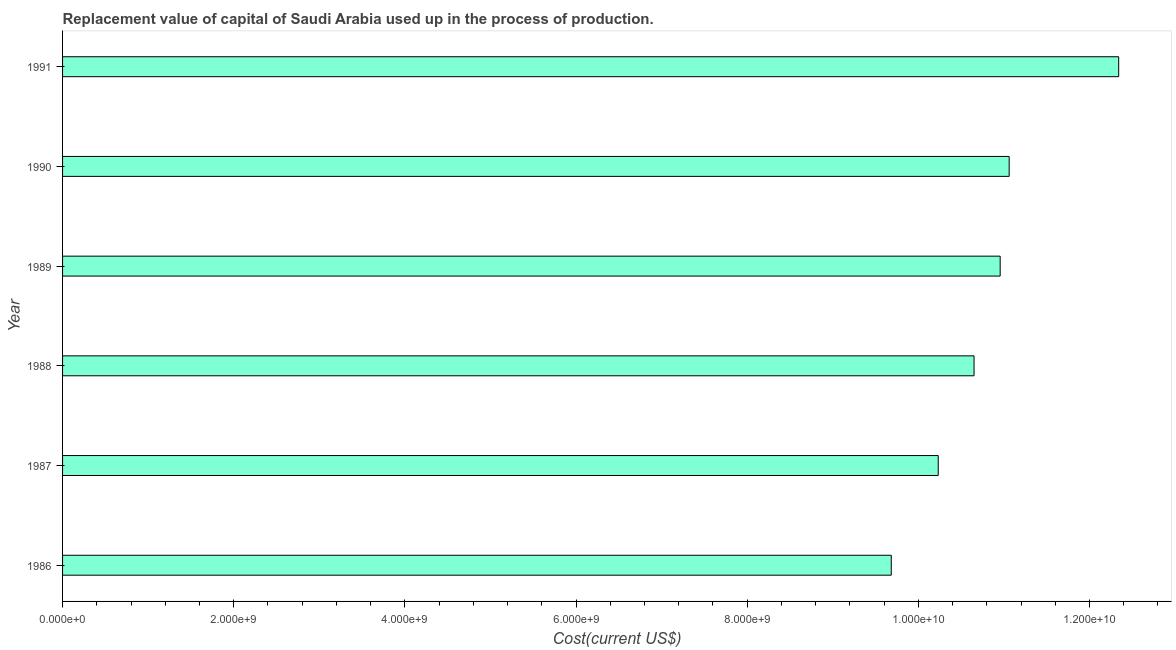Does the graph contain any zero values?
Give a very brief answer. No. Does the graph contain grids?
Offer a very short reply. No. What is the title of the graph?
Provide a short and direct response. Replacement value of capital of Saudi Arabia used up in the process of production. What is the label or title of the X-axis?
Ensure brevity in your answer.  Cost(current US$). What is the consumption of fixed capital in 1986?
Make the answer very short. 9.68e+09. Across all years, what is the maximum consumption of fixed capital?
Provide a short and direct response. 1.23e+1. Across all years, what is the minimum consumption of fixed capital?
Your answer should be very brief. 9.68e+09. In which year was the consumption of fixed capital maximum?
Give a very brief answer. 1991. In which year was the consumption of fixed capital minimum?
Your answer should be very brief. 1986. What is the sum of the consumption of fixed capital?
Provide a succinct answer. 6.49e+1. What is the difference between the consumption of fixed capital in 1986 and 1988?
Give a very brief answer. -9.67e+08. What is the average consumption of fixed capital per year?
Keep it short and to the point. 1.08e+1. What is the median consumption of fixed capital?
Your answer should be compact. 1.08e+1. Do a majority of the years between 1986 and 1990 (inclusive) have consumption of fixed capital greater than 6800000000 US$?
Offer a terse response. Yes. What is the ratio of the consumption of fixed capital in 1987 to that in 1991?
Make the answer very short. 0.83. Is the difference between the consumption of fixed capital in 1986 and 1990 greater than the difference between any two years?
Offer a very short reply. No. What is the difference between the highest and the second highest consumption of fixed capital?
Keep it short and to the point. 1.28e+09. What is the difference between the highest and the lowest consumption of fixed capital?
Give a very brief answer. 2.66e+09. In how many years, is the consumption of fixed capital greater than the average consumption of fixed capital taken over all years?
Make the answer very short. 3. How many years are there in the graph?
Give a very brief answer. 6. What is the difference between two consecutive major ticks on the X-axis?
Make the answer very short. 2.00e+09. What is the Cost(current US$) in 1986?
Provide a succinct answer. 9.68e+09. What is the Cost(current US$) in 1987?
Give a very brief answer. 1.02e+1. What is the Cost(current US$) of 1988?
Provide a short and direct response. 1.07e+1. What is the Cost(current US$) in 1989?
Ensure brevity in your answer.  1.10e+1. What is the Cost(current US$) of 1990?
Provide a short and direct response. 1.11e+1. What is the Cost(current US$) of 1991?
Provide a short and direct response. 1.23e+1. What is the difference between the Cost(current US$) in 1986 and 1987?
Make the answer very short. -5.49e+08. What is the difference between the Cost(current US$) in 1986 and 1988?
Offer a terse response. -9.67e+08. What is the difference between the Cost(current US$) in 1986 and 1989?
Offer a very short reply. -1.27e+09. What is the difference between the Cost(current US$) in 1986 and 1990?
Give a very brief answer. -1.38e+09. What is the difference between the Cost(current US$) in 1986 and 1991?
Your answer should be compact. -2.66e+09. What is the difference between the Cost(current US$) in 1987 and 1988?
Your answer should be very brief. -4.19e+08. What is the difference between the Cost(current US$) in 1987 and 1989?
Provide a succinct answer. -7.24e+08. What is the difference between the Cost(current US$) in 1987 and 1990?
Make the answer very short. -8.29e+08. What is the difference between the Cost(current US$) in 1987 and 1991?
Ensure brevity in your answer.  -2.11e+09. What is the difference between the Cost(current US$) in 1988 and 1989?
Offer a terse response. -3.05e+08. What is the difference between the Cost(current US$) in 1988 and 1990?
Give a very brief answer. -4.11e+08. What is the difference between the Cost(current US$) in 1988 and 1991?
Your response must be concise. -1.69e+09. What is the difference between the Cost(current US$) in 1989 and 1990?
Keep it short and to the point. -1.05e+08. What is the difference between the Cost(current US$) in 1989 and 1991?
Offer a terse response. -1.39e+09. What is the difference between the Cost(current US$) in 1990 and 1991?
Give a very brief answer. -1.28e+09. What is the ratio of the Cost(current US$) in 1986 to that in 1987?
Your answer should be very brief. 0.95. What is the ratio of the Cost(current US$) in 1986 to that in 1988?
Make the answer very short. 0.91. What is the ratio of the Cost(current US$) in 1986 to that in 1989?
Provide a short and direct response. 0.88. What is the ratio of the Cost(current US$) in 1986 to that in 1991?
Your answer should be compact. 0.79. What is the ratio of the Cost(current US$) in 1987 to that in 1988?
Give a very brief answer. 0.96. What is the ratio of the Cost(current US$) in 1987 to that in 1989?
Make the answer very short. 0.93. What is the ratio of the Cost(current US$) in 1987 to that in 1990?
Give a very brief answer. 0.93. What is the ratio of the Cost(current US$) in 1987 to that in 1991?
Provide a succinct answer. 0.83. What is the ratio of the Cost(current US$) in 1988 to that in 1990?
Provide a succinct answer. 0.96. What is the ratio of the Cost(current US$) in 1988 to that in 1991?
Your response must be concise. 0.86. What is the ratio of the Cost(current US$) in 1989 to that in 1990?
Give a very brief answer. 0.99. What is the ratio of the Cost(current US$) in 1989 to that in 1991?
Ensure brevity in your answer.  0.89. What is the ratio of the Cost(current US$) in 1990 to that in 1991?
Keep it short and to the point. 0.9. 